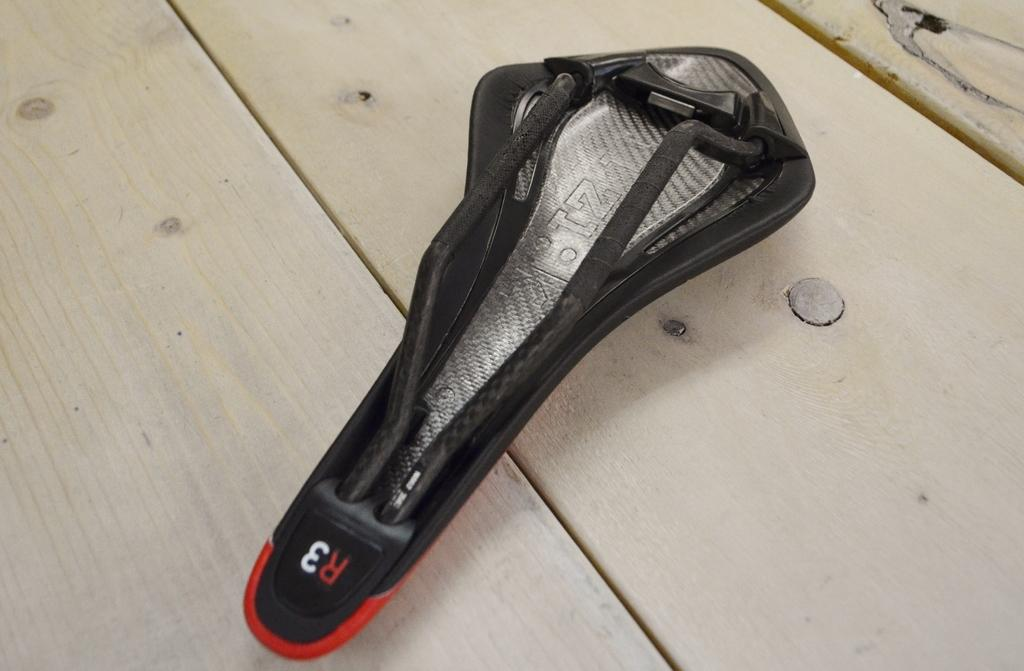What is the color of the object in the image? The object in the image is black. What type of surface is the black object placed on? The black object is placed on a wooden surface. What type of development is taking place in the image? There is no development taking place in the image; it only features a black object on a wooden surface. What type of fuel is being used by the black object in the image? The black object in the image is not using any fuel, as it is a stationary object on a wooden surface. 